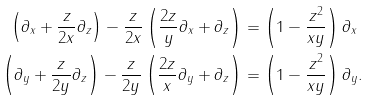Convert formula to latex. <formula><loc_0><loc_0><loc_500><loc_500>\left ( \partial _ { x } + \frac { z } { 2 x } \partial _ { z } \right ) - \frac { z } { 2 x } \left ( \frac { 2 z } { y } \partial _ { x } + \partial _ { z } \right ) & = \left ( 1 - \frac { z ^ { 2 } } { x y } \right ) \partial _ { x } \\ \left ( \partial _ { y } + \frac { z } { 2 y } \partial _ { z } \right ) - \frac { z } { 2 y } \left ( \frac { 2 z } { x } \partial _ { y } + \partial _ { z } \right ) & = \left ( 1 - \frac { z ^ { 2 } } { x y } \right ) \partial _ { y } .</formula> 